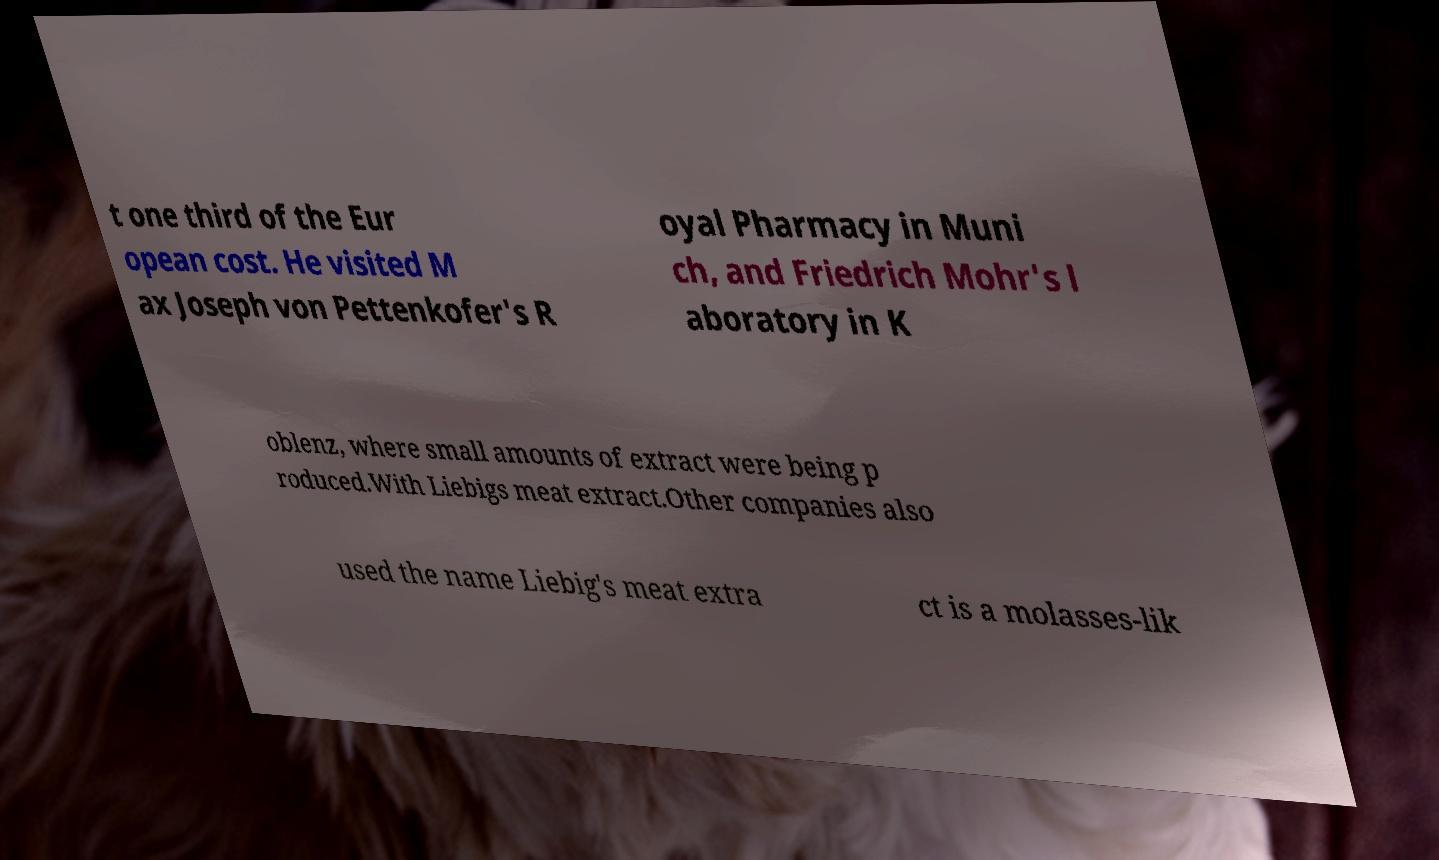Could you extract and type out the text from this image? t one third of the Eur opean cost. He visited M ax Joseph von Pettenkofer's R oyal Pharmacy in Muni ch, and Friedrich Mohr's l aboratory in K oblenz, where small amounts of extract were being p roduced.With Liebigs meat extract.Other companies also used the name Liebig's meat extra ct is a molasses-lik 